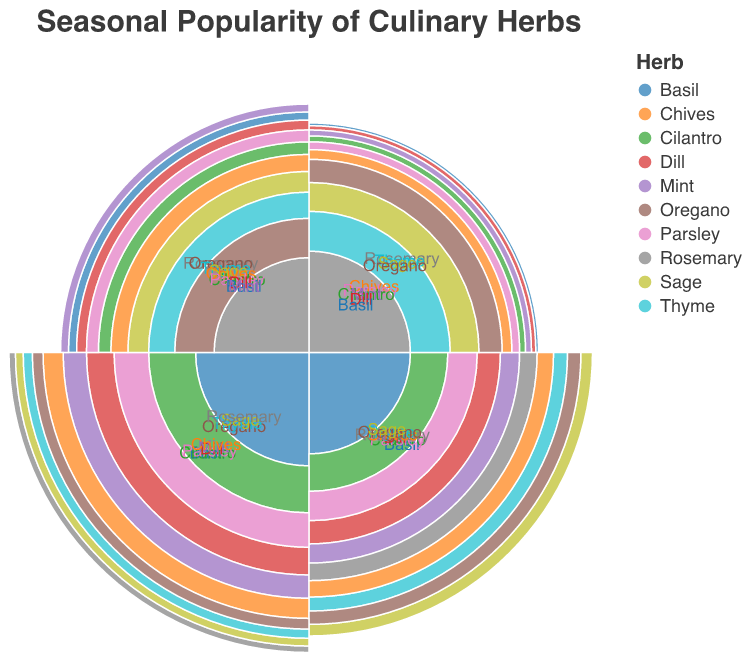What is the title of the figure? The title is prominently displayed at the top center of the figure, indicating the main focus of the chart.
Answer: Seasonal Popularity of Culinary Herbs Which herb has the highest usage value in summer? By examining the outermost arcs for each herb in the segment labeled "Summer," we can identify the herb with the highest value.
Answer: Basil and Cilantro How does the popularity of Rosemary in winter compare to its popularity in summer? Look for the arc representing Rosemary in both winter and summer segments. Rosemary's value is higher in winter than in summer.
Answer: Higher in winter Which season shows the highest usage of all herbs combined? Visually sum up the radii lengths for each herb in each season. The summer season has the longest combined radii lengths.
Answer: Summer What is the difference in popularity between Mint in spring and autumn? Compare the arc lengths for Mint in the spring and autumn segments. Mint in spring has a value of 60 and in autumn 30, so the difference is 60 - 30 = 30.
Answer: 30 Which herb is almost equally popular in winter and autumn? Examine the arcs for each herb in the winter and autumn segments and look for similar arc lengths. The arcs for Rosemary in winter and autumn appear almost equal in length.
Answer: Rosemary During which seasons is Sage more popular than Oregano? Compare the arc lengths of Sage and Oregano in each season. Sage has higher values in winter, spring, and summer compared to Oregano in those seasons.
Answer: Winter, Spring, and Summer What is the average popularity value of Parsley across all seasons? Add the values of Parsley across all seasons (25 + 70 + 95 + 40) and divide by 4. The average is (25 + 70 + 95 + 40) / 4 = 57.5.
Answer: 57.5 In which season does Chives show its highest popularity? Identify the longest arc for Chives across the four seasons. The longest arc for Chives is found in the summer season.
Answer: Summer 